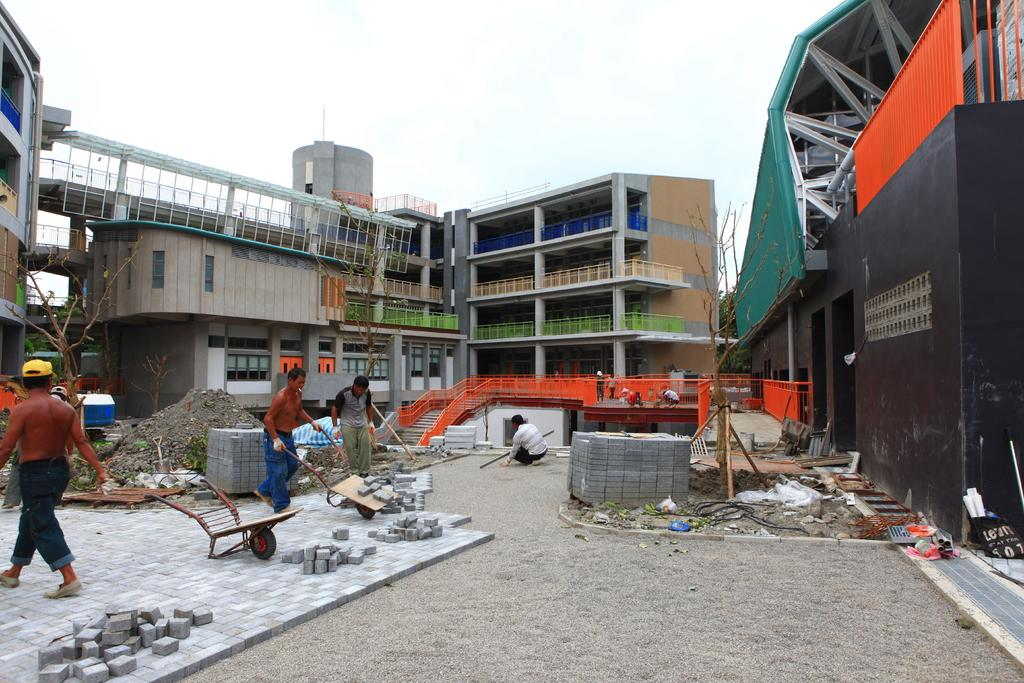What type of structures can be seen in the image? There are buildings in the image. Are there any living beings present in the image? Yes, there are people in the image. What material is used to construct the buildings? Bricks are present in the image, which suggests they might be used to construct the buildings. What type of vegetation is visible in the image? There are trees in the image. What else can be found on the ground in the image? There are other objects on the ground in the image. What is visible in the background of the image? The sky is visible in the background of the image. How long does it take for the seed to grow into a tree in the image? There is no seed present in the image, and therefore no growth process can be observed. What type of hose is being used by the people in the image? There is no hose present in the image. 